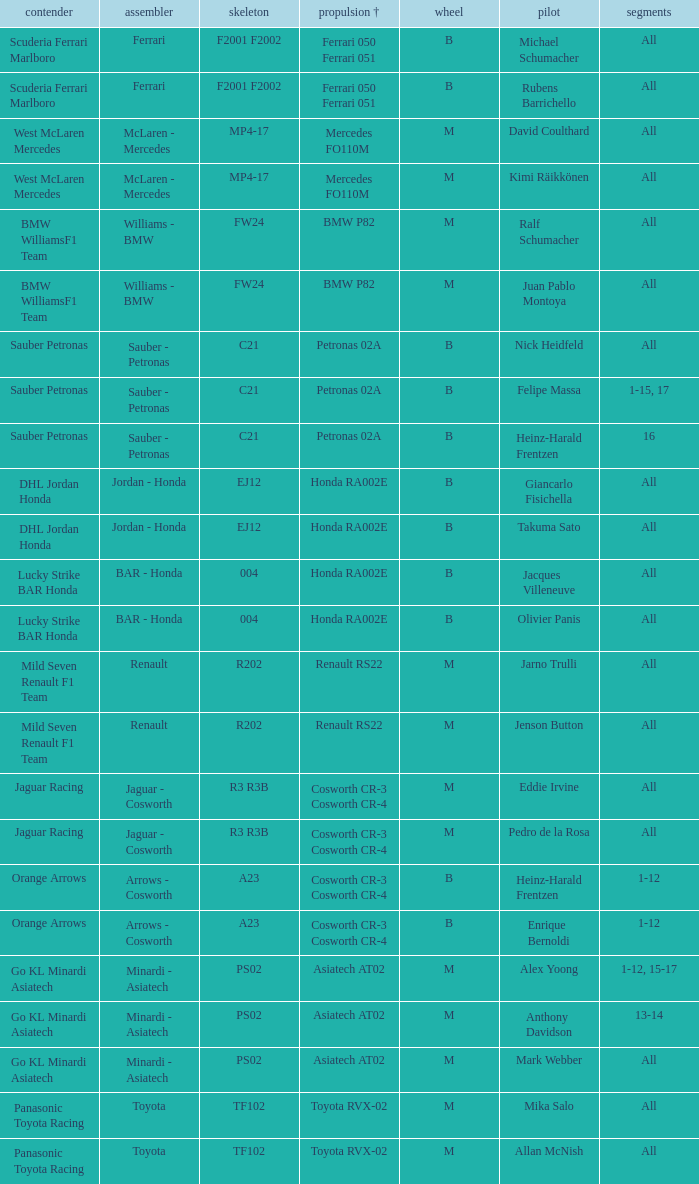What is the rounds when the engine is mercedes fo110m? All, All. 